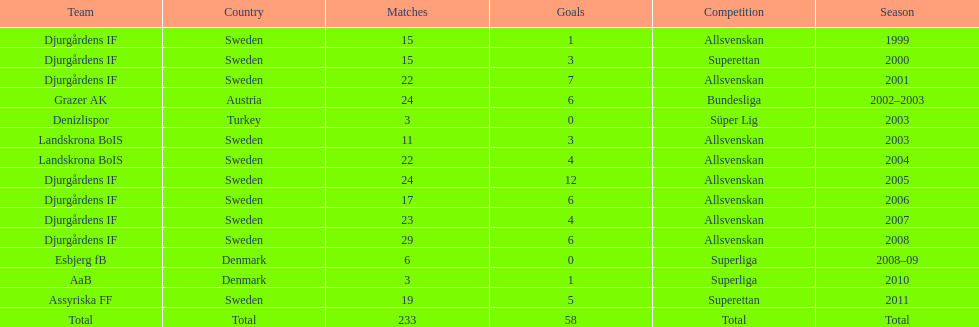What country is team djurgårdens if not from? Sweden. Give me the full table as a dictionary. {'header': ['Team', 'Country', 'Matches', 'Goals', 'Competition', 'Season'], 'rows': [['Djurgårdens IF', 'Sweden', '15', '1', 'Allsvenskan', '1999'], ['Djurgårdens IF', 'Sweden', '15', '3', 'Superettan', '2000'], ['Djurgårdens IF', 'Sweden', '22', '7', 'Allsvenskan', '2001'], ['Grazer AK', 'Austria', '24', '6', 'Bundesliga', '2002–2003'], ['Denizlispor', 'Turkey', '3', '0', 'Süper Lig', '2003'], ['Landskrona BoIS', 'Sweden', '11', '3', 'Allsvenskan', '2003'], ['Landskrona BoIS', 'Sweden', '22', '4', 'Allsvenskan', '2004'], ['Djurgårdens IF', 'Sweden', '24', '12', 'Allsvenskan', '2005'], ['Djurgårdens IF', 'Sweden', '17', '6', 'Allsvenskan', '2006'], ['Djurgårdens IF', 'Sweden', '23', '4', 'Allsvenskan', '2007'], ['Djurgårdens IF', 'Sweden', '29', '6', 'Allsvenskan', '2008'], ['Esbjerg fB', 'Denmark', '6', '0', 'Superliga', '2008–09'], ['AaB', 'Denmark', '3', '1', 'Superliga', '2010'], ['Assyriska FF', 'Sweden', '19', '5', 'Superettan', '2011'], ['Total', 'Total', '233', '58', 'Total', 'Total']]} 